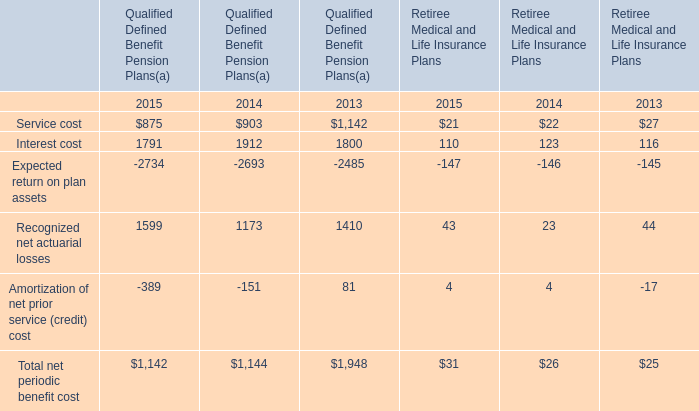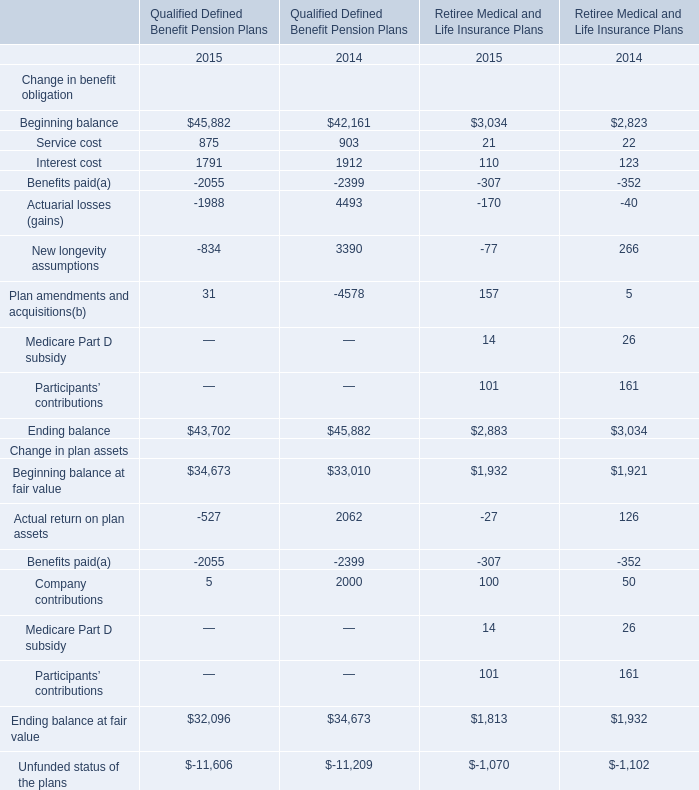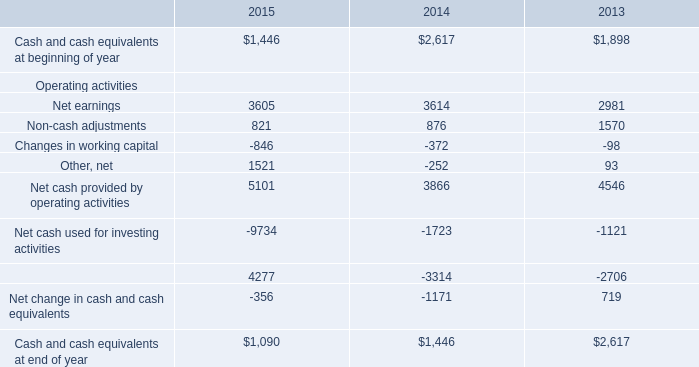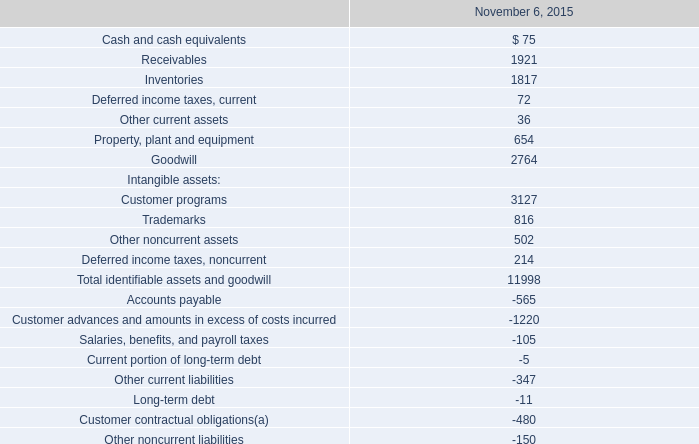what is the highest total amount of Interest cost? 
Answer: 1912. 